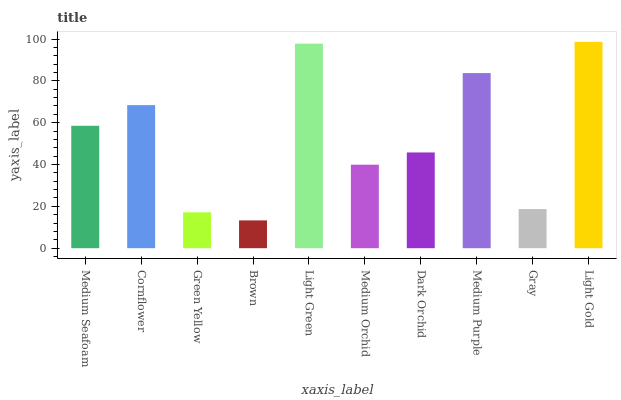Is Brown the minimum?
Answer yes or no. Yes. Is Light Gold the maximum?
Answer yes or no. Yes. Is Cornflower the minimum?
Answer yes or no. No. Is Cornflower the maximum?
Answer yes or no. No. Is Cornflower greater than Medium Seafoam?
Answer yes or no. Yes. Is Medium Seafoam less than Cornflower?
Answer yes or no. Yes. Is Medium Seafoam greater than Cornflower?
Answer yes or no. No. Is Cornflower less than Medium Seafoam?
Answer yes or no. No. Is Medium Seafoam the high median?
Answer yes or no. Yes. Is Dark Orchid the low median?
Answer yes or no. Yes. Is Medium Purple the high median?
Answer yes or no. No. Is Brown the low median?
Answer yes or no. No. 